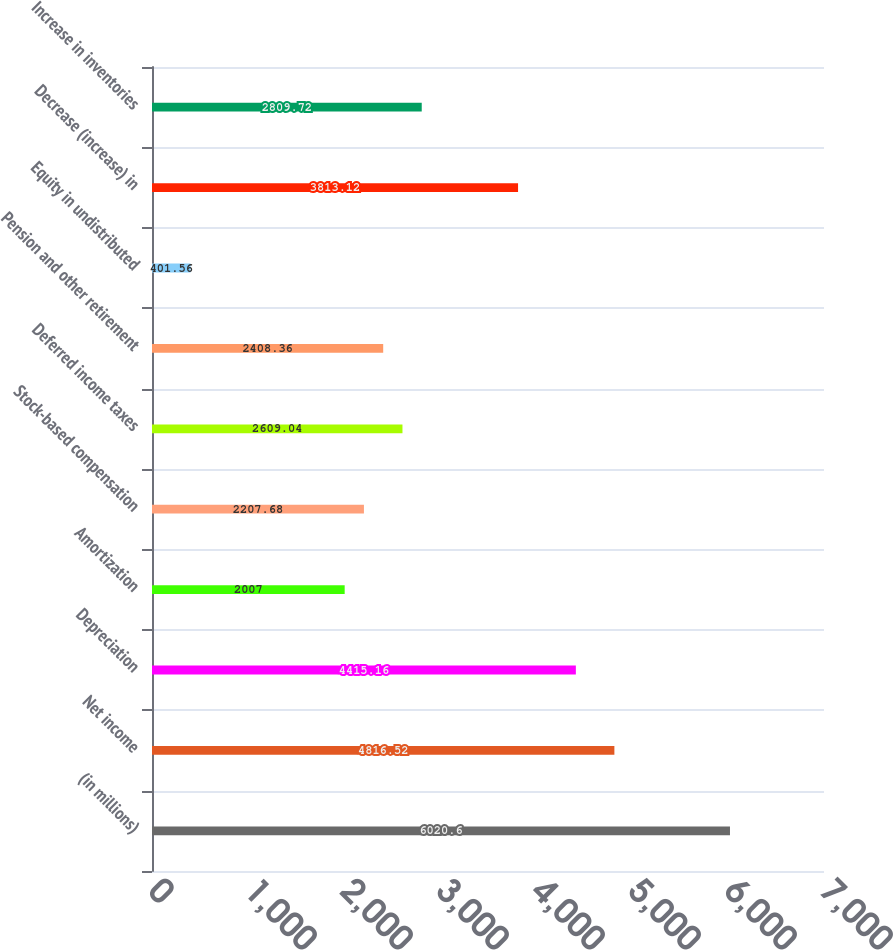Convert chart to OTSL. <chart><loc_0><loc_0><loc_500><loc_500><bar_chart><fcel>(in millions)<fcel>Net income<fcel>Depreciation<fcel>Amortization<fcel>Stock-based compensation<fcel>Deferred income taxes<fcel>Pension and other retirement<fcel>Equity in undistributed<fcel>Decrease (increase) in<fcel>Increase in inventories<nl><fcel>6020.6<fcel>4816.52<fcel>4415.16<fcel>2007<fcel>2207.68<fcel>2609.04<fcel>2408.36<fcel>401.56<fcel>3813.12<fcel>2809.72<nl></chart> 